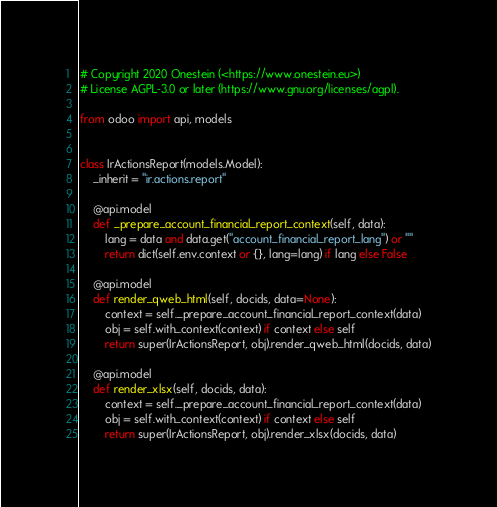<code> <loc_0><loc_0><loc_500><loc_500><_Python_># Copyright 2020 Onestein (<https://www.onestein.eu>)
# License AGPL-3.0 or later (https://www.gnu.org/licenses/agpl).

from odoo import api, models


class IrActionsReport(models.Model):
    _inherit = "ir.actions.report"

    @api.model
    def _prepare_account_financial_report_context(self, data):
        lang = data and data.get("account_financial_report_lang") or ""
        return dict(self.env.context or {}, lang=lang) if lang else False

    @api.model
    def render_qweb_html(self, docids, data=None):
        context = self._prepare_account_financial_report_context(data)
        obj = self.with_context(context) if context else self
        return super(IrActionsReport, obj).render_qweb_html(docids, data)

    @api.model
    def render_xlsx(self, docids, data):
        context = self._prepare_account_financial_report_context(data)
        obj = self.with_context(context) if context else self
        return super(IrActionsReport, obj).render_xlsx(docids, data)
</code> 